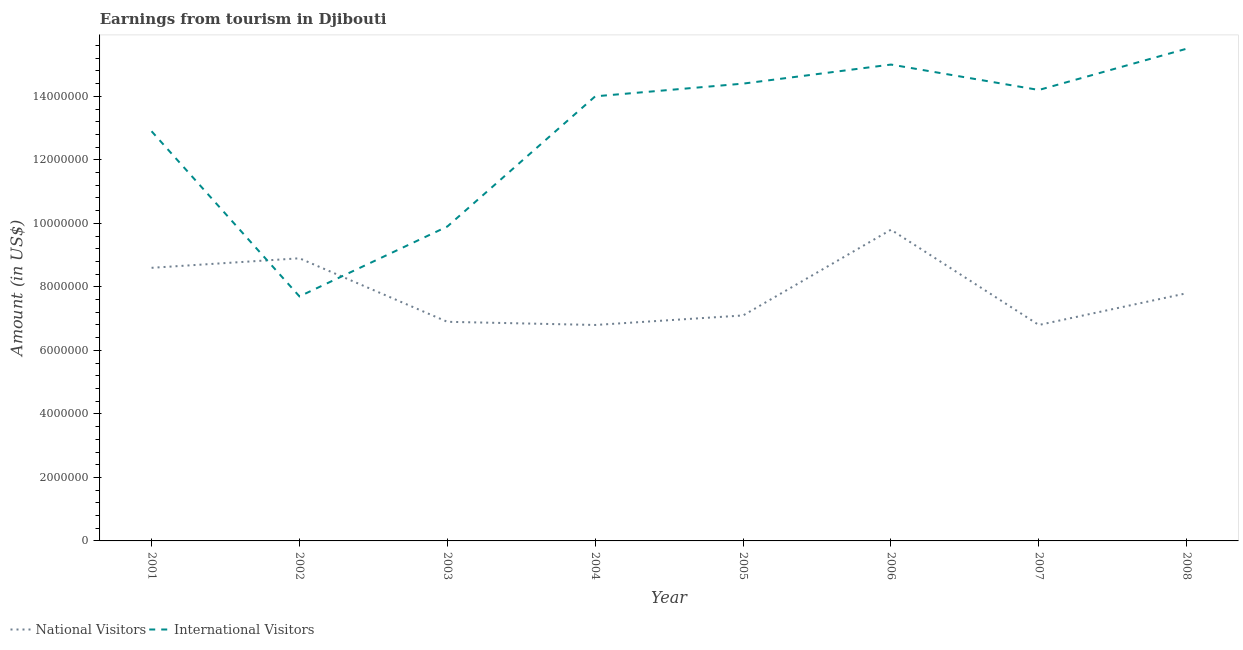How many different coloured lines are there?
Your answer should be very brief. 2. Does the line corresponding to amount earned from national visitors intersect with the line corresponding to amount earned from international visitors?
Your response must be concise. Yes. What is the amount earned from national visitors in 2006?
Give a very brief answer. 9.80e+06. Across all years, what is the maximum amount earned from international visitors?
Give a very brief answer. 1.55e+07. Across all years, what is the minimum amount earned from international visitors?
Your answer should be very brief. 7.70e+06. In which year was the amount earned from international visitors maximum?
Provide a succinct answer. 2008. What is the total amount earned from international visitors in the graph?
Offer a very short reply. 1.04e+08. What is the difference between the amount earned from national visitors in 2001 and that in 2005?
Your response must be concise. 1.50e+06. What is the difference between the amount earned from international visitors in 2004 and the amount earned from national visitors in 2006?
Your answer should be very brief. 4.20e+06. What is the average amount earned from national visitors per year?
Offer a terse response. 7.84e+06. In the year 2008, what is the difference between the amount earned from international visitors and amount earned from national visitors?
Give a very brief answer. 7.70e+06. What is the ratio of the amount earned from national visitors in 2002 to that in 2008?
Provide a short and direct response. 1.14. Is the difference between the amount earned from international visitors in 2004 and 2008 greater than the difference between the amount earned from national visitors in 2004 and 2008?
Provide a succinct answer. No. What is the difference between the highest and the lowest amount earned from national visitors?
Your response must be concise. 3.00e+06. In how many years, is the amount earned from national visitors greater than the average amount earned from national visitors taken over all years?
Keep it short and to the point. 3. Is the amount earned from international visitors strictly greater than the amount earned from national visitors over the years?
Provide a short and direct response. No. Is the amount earned from national visitors strictly less than the amount earned from international visitors over the years?
Your answer should be compact. No. How many lines are there?
Ensure brevity in your answer.  2. What is the difference between two consecutive major ticks on the Y-axis?
Offer a very short reply. 2.00e+06. Are the values on the major ticks of Y-axis written in scientific E-notation?
Your answer should be compact. No. Does the graph contain grids?
Offer a very short reply. No. Where does the legend appear in the graph?
Ensure brevity in your answer.  Bottom left. How are the legend labels stacked?
Your answer should be very brief. Horizontal. What is the title of the graph?
Keep it short and to the point. Earnings from tourism in Djibouti. Does "% of gross capital formation" appear as one of the legend labels in the graph?
Your answer should be very brief. No. What is the label or title of the Y-axis?
Your answer should be compact. Amount (in US$). What is the Amount (in US$) of National Visitors in 2001?
Give a very brief answer. 8.60e+06. What is the Amount (in US$) in International Visitors in 2001?
Keep it short and to the point. 1.29e+07. What is the Amount (in US$) in National Visitors in 2002?
Provide a succinct answer. 8.90e+06. What is the Amount (in US$) of International Visitors in 2002?
Ensure brevity in your answer.  7.70e+06. What is the Amount (in US$) in National Visitors in 2003?
Offer a terse response. 6.90e+06. What is the Amount (in US$) in International Visitors in 2003?
Make the answer very short. 9.90e+06. What is the Amount (in US$) in National Visitors in 2004?
Offer a very short reply. 6.80e+06. What is the Amount (in US$) of International Visitors in 2004?
Ensure brevity in your answer.  1.40e+07. What is the Amount (in US$) of National Visitors in 2005?
Your response must be concise. 7.10e+06. What is the Amount (in US$) of International Visitors in 2005?
Ensure brevity in your answer.  1.44e+07. What is the Amount (in US$) of National Visitors in 2006?
Offer a very short reply. 9.80e+06. What is the Amount (in US$) of International Visitors in 2006?
Your response must be concise. 1.50e+07. What is the Amount (in US$) of National Visitors in 2007?
Give a very brief answer. 6.80e+06. What is the Amount (in US$) of International Visitors in 2007?
Provide a short and direct response. 1.42e+07. What is the Amount (in US$) in National Visitors in 2008?
Keep it short and to the point. 7.80e+06. What is the Amount (in US$) of International Visitors in 2008?
Your response must be concise. 1.55e+07. Across all years, what is the maximum Amount (in US$) in National Visitors?
Provide a short and direct response. 9.80e+06. Across all years, what is the maximum Amount (in US$) of International Visitors?
Keep it short and to the point. 1.55e+07. Across all years, what is the minimum Amount (in US$) in National Visitors?
Offer a terse response. 6.80e+06. Across all years, what is the minimum Amount (in US$) of International Visitors?
Your response must be concise. 7.70e+06. What is the total Amount (in US$) in National Visitors in the graph?
Your answer should be compact. 6.27e+07. What is the total Amount (in US$) in International Visitors in the graph?
Provide a short and direct response. 1.04e+08. What is the difference between the Amount (in US$) in National Visitors in 2001 and that in 2002?
Provide a short and direct response. -3.00e+05. What is the difference between the Amount (in US$) in International Visitors in 2001 and that in 2002?
Provide a succinct answer. 5.20e+06. What is the difference between the Amount (in US$) in National Visitors in 2001 and that in 2003?
Your response must be concise. 1.70e+06. What is the difference between the Amount (in US$) in International Visitors in 2001 and that in 2003?
Your response must be concise. 3.00e+06. What is the difference between the Amount (in US$) in National Visitors in 2001 and that in 2004?
Your answer should be very brief. 1.80e+06. What is the difference between the Amount (in US$) of International Visitors in 2001 and that in 2004?
Offer a terse response. -1.10e+06. What is the difference between the Amount (in US$) of National Visitors in 2001 and that in 2005?
Keep it short and to the point. 1.50e+06. What is the difference between the Amount (in US$) in International Visitors in 2001 and that in 2005?
Provide a short and direct response. -1.50e+06. What is the difference between the Amount (in US$) in National Visitors in 2001 and that in 2006?
Give a very brief answer. -1.20e+06. What is the difference between the Amount (in US$) in International Visitors in 2001 and that in 2006?
Provide a short and direct response. -2.10e+06. What is the difference between the Amount (in US$) in National Visitors in 2001 and that in 2007?
Ensure brevity in your answer.  1.80e+06. What is the difference between the Amount (in US$) of International Visitors in 2001 and that in 2007?
Your response must be concise. -1.30e+06. What is the difference between the Amount (in US$) in National Visitors in 2001 and that in 2008?
Ensure brevity in your answer.  8.00e+05. What is the difference between the Amount (in US$) of International Visitors in 2001 and that in 2008?
Your response must be concise. -2.60e+06. What is the difference between the Amount (in US$) of International Visitors in 2002 and that in 2003?
Your response must be concise. -2.20e+06. What is the difference between the Amount (in US$) of National Visitors in 2002 and that in 2004?
Your response must be concise. 2.10e+06. What is the difference between the Amount (in US$) of International Visitors in 2002 and that in 2004?
Keep it short and to the point. -6.30e+06. What is the difference between the Amount (in US$) of National Visitors in 2002 and that in 2005?
Offer a terse response. 1.80e+06. What is the difference between the Amount (in US$) in International Visitors in 2002 and that in 2005?
Your answer should be compact. -6.70e+06. What is the difference between the Amount (in US$) of National Visitors in 2002 and that in 2006?
Make the answer very short. -9.00e+05. What is the difference between the Amount (in US$) of International Visitors in 2002 and that in 2006?
Offer a terse response. -7.30e+06. What is the difference between the Amount (in US$) of National Visitors in 2002 and that in 2007?
Ensure brevity in your answer.  2.10e+06. What is the difference between the Amount (in US$) of International Visitors in 2002 and that in 2007?
Provide a short and direct response. -6.50e+06. What is the difference between the Amount (in US$) of National Visitors in 2002 and that in 2008?
Offer a very short reply. 1.10e+06. What is the difference between the Amount (in US$) in International Visitors in 2002 and that in 2008?
Your answer should be very brief. -7.80e+06. What is the difference between the Amount (in US$) of International Visitors in 2003 and that in 2004?
Keep it short and to the point. -4.10e+06. What is the difference between the Amount (in US$) of International Visitors in 2003 and that in 2005?
Make the answer very short. -4.50e+06. What is the difference between the Amount (in US$) in National Visitors in 2003 and that in 2006?
Your response must be concise. -2.90e+06. What is the difference between the Amount (in US$) in International Visitors in 2003 and that in 2006?
Provide a succinct answer. -5.10e+06. What is the difference between the Amount (in US$) of International Visitors in 2003 and that in 2007?
Keep it short and to the point. -4.30e+06. What is the difference between the Amount (in US$) of National Visitors in 2003 and that in 2008?
Provide a succinct answer. -9.00e+05. What is the difference between the Amount (in US$) of International Visitors in 2003 and that in 2008?
Offer a terse response. -5.60e+06. What is the difference between the Amount (in US$) in National Visitors in 2004 and that in 2005?
Your answer should be compact. -3.00e+05. What is the difference between the Amount (in US$) of International Visitors in 2004 and that in 2005?
Offer a very short reply. -4.00e+05. What is the difference between the Amount (in US$) in National Visitors in 2004 and that in 2007?
Keep it short and to the point. 0. What is the difference between the Amount (in US$) in National Visitors in 2004 and that in 2008?
Your answer should be very brief. -1.00e+06. What is the difference between the Amount (in US$) in International Visitors in 2004 and that in 2008?
Your response must be concise. -1.50e+06. What is the difference between the Amount (in US$) in National Visitors in 2005 and that in 2006?
Provide a short and direct response. -2.70e+06. What is the difference between the Amount (in US$) in International Visitors in 2005 and that in 2006?
Give a very brief answer. -6.00e+05. What is the difference between the Amount (in US$) of National Visitors in 2005 and that in 2007?
Your response must be concise. 3.00e+05. What is the difference between the Amount (in US$) in National Visitors in 2005 and that in 2008?
Your answer should be very brief. -7.00e+05. What is the difference between the Amount (in US$) of International Visitors in 2005 and that in 2008?
Ensure brevity in your answer.  -1.10e+06. What is the difference between the Amount (in US$) in International Visitors in 2006 and that in 2008?
Ensure brevity in your answer.  -5.00e+05. What is the difference between the Amount (in US$) in National Visitors in 2007 and that in 2008?
Give a very brief answer. -1.00e+06. What is the difference between the Amount (in US$) of International Visitors in 2007 and that in 2008?
Your answer should be very brief. -1.30e+06. What is the difference between the Amount (in US$) in National Visitors in 2001 and the Amount (in US$) in International Visitors in 2002?
Offer a terse response. 9.00e+05. What is the difference between the Amount (in US$) of National Visitors in 2001 and the Amount (in US$) of International Visitors in 2003?
Keep it short and to the point. -1.30e+06. What is the difference between the Amount (in US$) in National Visitors in 2001 and the Amount (in US$) in International Visitors in 2004?
Offer a very short reply. -5.40e+06. What is the difference between the Amount (in US$) in National Visitors in 2001 and the Amount (in US$) in International Visitors in 2005?
Provide a short and direct response. -5.80e+06. What is the difference between the Amount (in US$) of National Visitors in 2001 and the Amount (in US$) of International Visitors in 2006?
Offer a very short reply. -6.40e+06. What is the difference between the Amount (in US$) in National Visitors in 2001 and the Amount (in US$) in International Visitors in 2007?
Provide a short and direct response. -5.60e+06. What is the difference between the Amount (in US$) of National Visitors in 2001 and the Amount (in US$) of International Visitors in 2008?
Your response must be concise. -6.90e+06. What is the difference between the Amount (in US$) of National Visitors in 2002 and the Amount (in US$) of International Visitors in 2003?
Your answer should be compact. -1.00e+06. What is the difference between the Amount (in US$) of National Visitors in 2002 and the Amount (in US$) of International Visitors in 2004?
Provide a short and direct response. -5.10e+06. What is the difference between the Amount (in US$) of National Visitors in 2002 and the Amount (in US$) of International Visitors in 2005?
Provide a succinct answer. -5.50e+06. What is the difference between the Amount (in US$) of National Visitors in 2002 and the Amount (in US$) of International Visitors in 2006?
Make the answer very short. -6.10e+06. What is the difference between the Amount (in US$) in National Visitors in 2002 and the Amount (in US$) in International Visitors in 2007?
Give a very brief answer. -5.30e+06. What is the difference between the Amount (in US$) in National Visitors in 2002 and the Amount (in US$) in International Visitors in 2008?
Provide a succinct answer. -6.60e+06. What is the difference between the Amount (in US$) in National Visitors in 2003 and the Amount (in US$) in International Visitors in 2004?
Provide a short and direct response. -7.10e+06. What is the difference between the Amount (in US$) in National Visitors in 2003 and the Amount (in US$) in International Visitors in 2005?
Give a very brief answer. -7.50e+06. What is the difference between the Amount (in US$) of National Visitors in 2003 and the Amount (in US$) of International Visitors in 2006?
Your answer should be compact. -8.10e+06. What is the difference between the Amount (in US$) in National Visitors in 2003 and the Amount (in US$) in International Visitors in 2007?
Your answer should be very brief. -7.30e+06. What is the difference between the Amount (in US$) in National Visitors in 2003 and the Amount (in US$) in International Visitors in 2008?
Your answer should be very brief. -8.60e+06. What is the difference between the Amount (in US$) in National Visitors in 2004 and the Amount (in US$) in International Visitors in 2005?
Your answer should be compact. -7.60e+06. What is the difference between the Amount (in US$) in National Visitors in 2004 and the Amount (in US$) in International Visitors in 2006?
Your answer should be very brief. -8.20e+06. What is the difference between the Amount (in US$) in National Visitors in 2004 and the Amount (in US$) in International Visitors in 2007?
Your answer should be very brief. -7.40e+06. What is the difference between the Amount (in US$) of National Visitors in 2004 and the Amount (in US$) of International Visitors in 2008?
Your answer should be compact. -8.70e+06. What is the difference between the Amount (in US$) in National Visitors in 2005 and the Amount (in US$) in International Visitors in 2006?
Keep it short and to the point. -7.90e+06. What is the difference between the Amount (in US$) of National Visitors in 2005 and the Amount (in US$) of International Visitors in 2007?
Provide a short and direct response. -7.10e+06. What is the difference between the Amount (in US$) in National Visitors in 2005 and the Amount (in US$) in International Visitors in 2008?
Your response must be concise. -8.40e+06. What is the difference between the Amount (in US$) of National Visitors in 2006 and the Amount (in US$) of International Visitors in 2007?
Make the answer very short. -4.40e+06. What is the difference between the Amount (in US$) of National Visitors in 2006 and the Amount (in US$) of International Visitors in 2008?
Your answer should be very brief. -5.70e+06. What is the difference between the Amount (in US$) in National Visitors in 2007 and the Amount (in US$) in International Visitors in 2008?
Ensure brevity in your answer.  -8.70e+06. What is the average Amount (in US$) of National Visitors per year?
Give a very brief answer. 7.84e+06. What is the average Amount (in US$) in International Visitors per year?
Keep it short and to the point. 1.30e+07. In the year 2001, what is the difference between the Amount (in US$) of National Visitors and Amount (in US$) of International Visitors?
Offer a very short reply. -4.30e+06. In the year 2002, what is the difference between the Amount (in US$) in National Visitors and Amount (in US$) in International Visitors?
Keep it short and to the point. 1.20e+06. In the year 2003, what is the difference between the Amount (in US$) in National Visitors and Amount (in US$) in International Visitors?
Give a very brief answer. -3.00e+06. In the year 2004, what is the difference between the Amount (in US$) of National Visitors and Amount (in US$) of International Visitors?
Provide a short and direct response. -7.20e+06. In the year 2005, what is the difference between the Amount (in US$) in National Visitors and Amount (in US$) in International Visitors?
Offer a terse response. -7.30e+06. In the year 2006, what is the difference between the Amount (in US$) in National Visitors and Amount (in US$) in International Visitors?
Your response must be concise. -5.20e+06. In the year 2007, what is the difference between the Amount (in US$) in National Visitors and Amount (in US$) in International Visitors?
Your answer should be very brief. -7.40e+06. In the year 2008, what is the difference between the Amount (in US$) in National Visitors and Amount (in US$) in International Visitors?
Your answer should be compact. -7.70e+06. What is the ratio of the Amount (in US$) of National Visitors in 2001 to that in 2002?
Provide a succinct answer. 0.97. What is the ratio of the Amount (in US$) of International Visitors in 2001 to that in 2002?
Make the answer very short. 1.68. What is the ratio of the Amount (in US$) of National Visitors in 2001 to that in 2003?
Provide a succinct answer. 1.25. What is the ratio of the Amount (in US$) in International Visitors in 2001 to that in 2003?
Provide a succinct answer. 1.3. What is the ratio of the Amount (in US$) of National Visitors in 2001 to that in 2004?
Offer a very short reply. 1.26. What is the ratio of the Amount (in US$) of International Visitors in 2001 to that in 2004?
Your answer should be very brief. 0.92. What is the ratio of the Amount (in US$) in National Visitors in 2001 to that in 2005?
Offer a very short reply. 1.21. What is the ratio of the Amount (in US$) in International Visitors in 2001 to that in 2005?
Keep it short and to the point. 0.9. What is the ratio of the Amount (in US$) in National Visitors in 2001 to that in 2006?
Your response must be concise. 0.88. What is the ratio of the Amount (in US$) of International Visitors in 2001 to that in 2006?
Provide a short and direct response. 0.86. What is the ratio of the Amount (in US$) of National Visitors in 2001 to that in 2007?
Keep it short and to the point. 1.26. What is the ratio of the Amount (in US$) of International Visitors in 2001 to that in 2007?
Your response must be concise. 0.91. What is the ratio of the Amount (in US$) in National Visitors in 2001 to that in 2008?
Ensure brevity in your answer.  1.1. What is the ratio of the Amount (in US$) in International Visitors in 2001 to that in 2008?
Offer a terse response. 0.83. What is the ratio of the Amount (in US$) of National Visitors in 2002 to that in 2003?
Offer a very short reply. 1.29. What is the ratio of the Amount (in US$) in International Visitors in 2002 to that in 2003?
Keep it short and to the point. 0.78. What is the ratio of the Amount (in US$) in National Visitors in 2002 to that in 2004?
Your answer should be very brief. 1.31. What is the ratio of the Amount (in US$) in International Visitors in 2002 to that in 2004?
Make the answer very short. 0.55. What is the ratio of the Amount (in US$) in National Visitors in 2002 to that in 2005?
Provide a succinct answer. 1.25. What is the ratio of the Amount (in US$) in International Visitors in 2002 to that in 2005?
Your answer should be compact. 0.53. What is the ratio of the Amount (in US$) of National Visitors in 2002 to that in 2006?
Ensure brevity in your answer.  0.91. What is the ratio of the Amount (in US$) of International Visitors in 2002 to that in 2006?
Your answer should be very brief. 0.51. What is the ratio of the Amount (in US$) of National Visitors in 2002 to that in 2007?
Your answer should be compact. 1.31. What is the ratio of the Amount (in US$) of International Visitors in 2002 to that in 2007?
Your response must be concise. 0.54. What is the ratio of the Amount (in US$) in National Visitors in 2002 to that in 2008?
Make the answer very short. 1.14. What is the ratio of the Amount (in US$) of International Visitors in 2002 to that in 2008?
Give a very brief answer. 0.5. What is the ratio of the Amount (in US$) of National Visitors in 2003 to that in 2004?
Your answer should be compact. 1.01. What is the ratio of the Amount (in US$) in International Visitors in 2003 to that in 2004?
Offer a terse response. 0.71. What is the ratio of the Amount (in US$) in National Visitors in 2003 to that in 2005?
Your answer should be very brief. 0.97. What is the ratio of the Amount (in US$) in International Visitors in 2003 to that in 2005?
Offer a terse response. 0.69. What is the ratio of the Amount (in US$) in National Visitors in 2003 to that in 2006?
Your answer should be very brief. 0.7. What is the ratio of the Amount (in US$) in International Visitors in 2003 to that in 2006?
Your answer should be very brief. 0.66. What is the ratio of the Amount (in US$) of National Visitors in 2003 to that in 2007?
Your response must be concise. 1.01. What is the ratio of the Amount (in US$) of International Visitors in 2003 to that in 2007?
Provide a short and direct response. 0.7. What is the ratio of the Amount (in US$) of National Visitors in 2003 to that in 2008?
Provide a succinct answer. 0.88. What is the ratio of the Amount (in US$) of International Visitors in 2003 to that in 2008?
Ensure brevity in your answer.  0.64. What is the ratio of the Amount (in US$) in National Visitors in 2004 to that in 2005?
Keep it short and to the point. 0.96. What is the ratio of the Amount (in US$) in International Visitors in 2004 to that in 2005?
Offer a terse response. 0.97. What is the ratio of the Amount (in US$) of National Visitors in 2004 to that in 2006?
Provide a succinct answer. 0.69. What is the ratio of the Amount (in US$) in National Visitors in 2004 to that in 2007?
Offer a terse response. 1. What is the ratio of the Amount (in US$) in International Visitors in 2004 to that in 2007?
Provide a short and direct response. 0.99. What is the ratio of the Amount (in US$) in National Visitors in 2004 to that in 2008?
Provide a short and direct response. 0.87. What is the ratio of the Amount (in US$) of International Visitors in 2004 to that in 2008?
Give a very brief answer. 0.9. What is the ratio of the Amount (in US$) in National Visitors in 2005 to that in 2006?
Your answer should be very brief. 0.72. What is the ratio of the Amount (in US$) of International Visitors in 2005 to that in 2006?
Offer a terse response. 0.96. What is the ratio of the Amount (in US$) in National Visitors in 2005 to that in 2007?
Provide a short and direct response. 1.04. What is the ratio of the Amount (in US$) in International Visitors in 2005 to that in 2007?
Give a very brief answer. 1.01. What is the ratio of the Amount (in US$) in National Visitors in 2005 to that in 2008?
Provide a short and direct response. 0.91. What is the ratio of the Amount (in US$) in International Visitors in 2005 to that in 2008?
Give a very brief answer. 0.93. What is the ratio of the Amount (in US$) of National Visitors in 2006 to that in 2007?
Your answer should be compact. 1.44. What is the ratio of the Amount (in US$) in International Visitors in 2006 to that in 2007?
Offer a terse response. 1.06. What is the ratio of the Amount (in US$) in National Visitors in 2006 to that in 2008?
Keep it short and to the point. 1.26. What is the ratio of the Amount (in US$) of National Visitors in 2007 to that in 2008?
Provide a succinct answer. 0.87. What is the ratio of the Amount (in US$) of International Visitors in 2007 to that in 2008?
Your answer should be very brief. 0.92. What is the difference between the highest and the second highest Amount (in US$) in National Visitors?
Provide a short and direct response. 9.00e+05. What is the difference between the highest and the lowest Amount (in US$) in International Visitors?
Keep it short and to the point. 7.80e+06. 